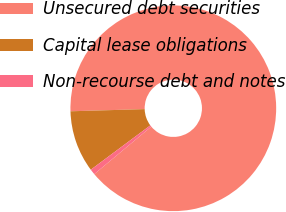<chart> <loc_0><loc_0><loc_500><loc_500><pie_chart><fcel>Unsecured debt securities<fcel>Capital lease obligations<fcel>Non-recourse debt and notes<nl><fcel>89.41%<fcel>9.72%<fcel>0.87%<nl></chart> 